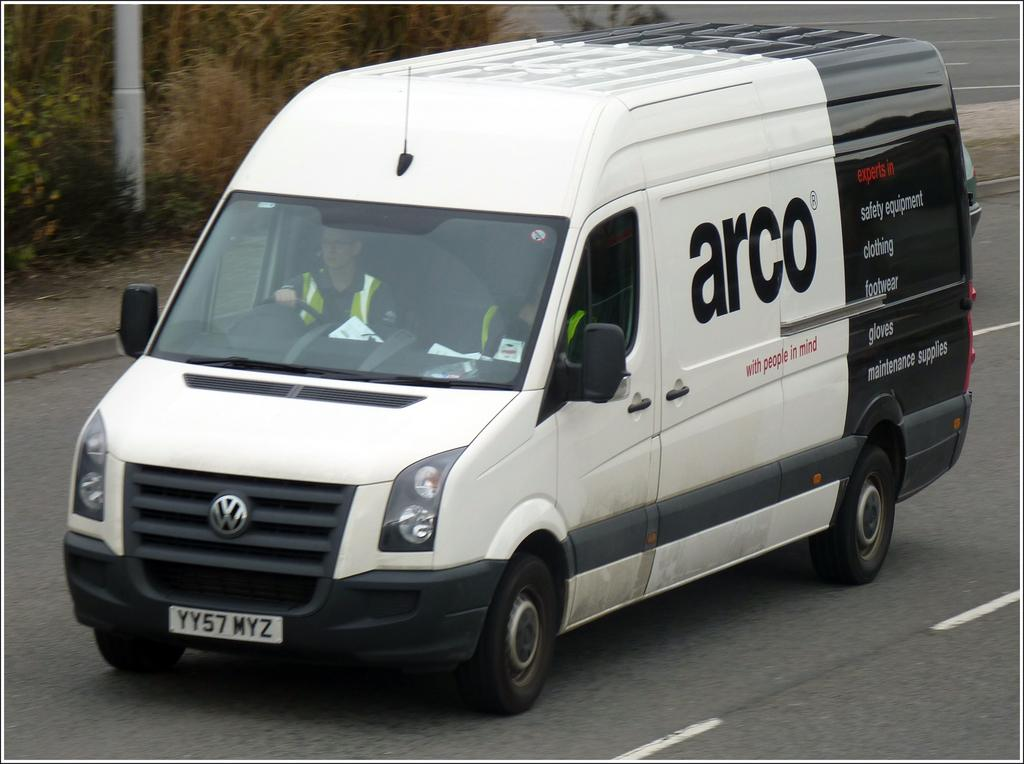<image>
Write a terse but informative summary of the picture. White and Black arco midsize delivery volks wagon van 